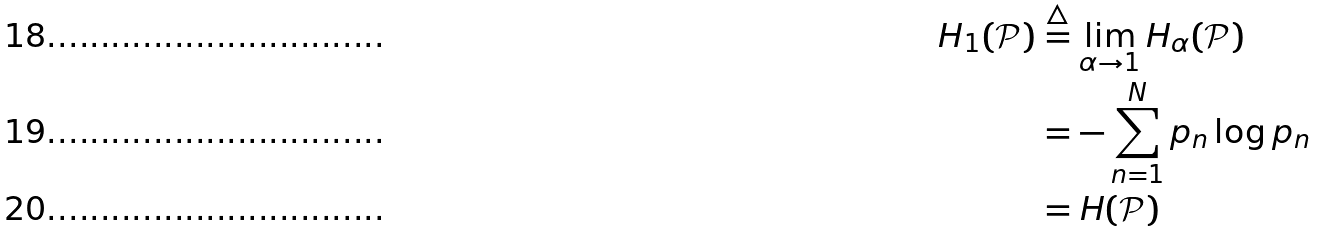<formula> <loc_0><loc_0><loc_500><loc_500>H _ { 1 } ( \mathcal { P } ) & \stackrel { \triangle } { = } \lim _ { \alpha \to 1 } H _ { \alpha } ( \mathcal { P } ) \\ & = - \sum _ { n = 1 } ^ { N } p _ { n } \log p _ { n } \\ & = H ( \mathcal { P } )</formula> 